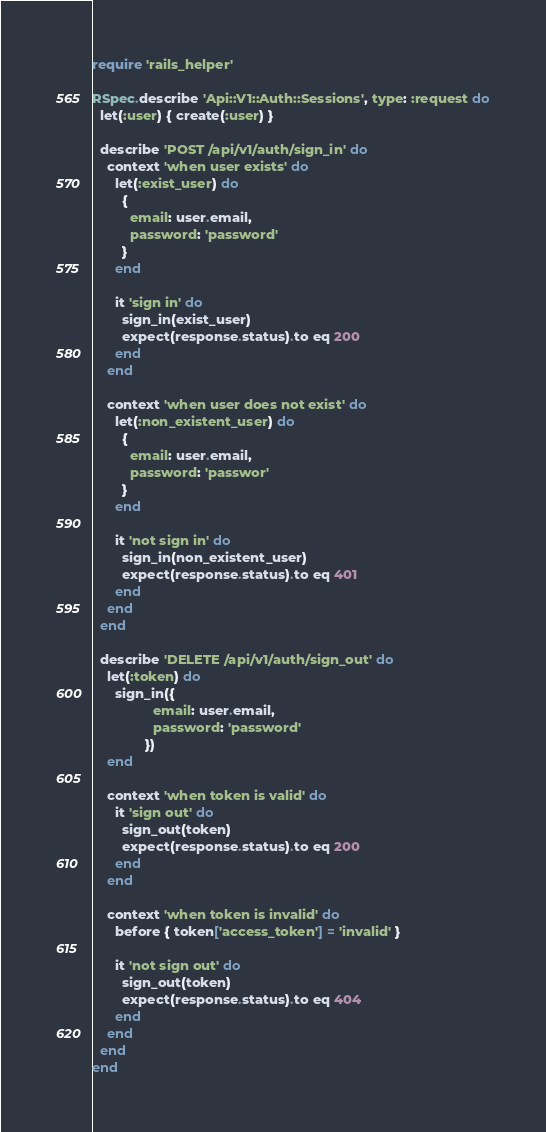<code> <loc_0><loc_0><loc_500><loc_500><_Ruby_>require 'rails_helper'

RSpec.describe 'Api::V1::Auth::Sessions', type: :request do
  let(:user) { create(:user) }

  describe 'POST /api/v1/auth/sign_in' do
    context 'when user exists' do
      let(:exist_user) do
        {
          email: user.email,
          password: 'password'
        }
      end

      it 'sign in' do
        sign_in(exist_user)
        expect(response.status).to eq 200
      end
    end

    context 'when user does not exist' do
      let(:non_existent_user) do
        {
          email: user.email,
          password: 'passwor'
        }
      end

      it 'not sign in' do
        sign_in(non_existent_user)
        expect(response.status).to eq 401
      end
    end
  end

  describe 'DELETE /api/v1/auth/sign_out' do
    let(:token) do
      sign_in({
                email: user.email,
                password: 'password'
              })
    end

    context 'when token is valid' do
      it 'sign out' do
        sign_out(token)
        expect(response.status).to eq 200
      end
    end

    context 'when token is invalid' do
      before { token['access_token'] = 'invalid' }

      it 'not sign out' do
        sign_out(token)
        expect(response.status).to eq 404
      end
    end
  end
end
</code> 